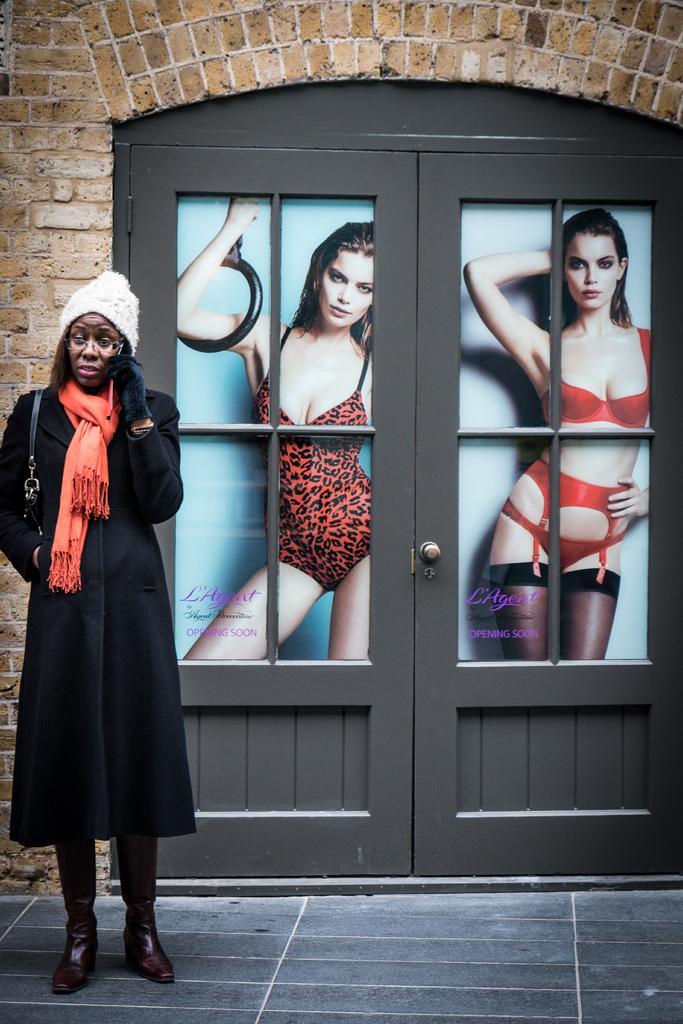Describe this image in one or two sentences. There is a woman standing on the floor and she has spectacles. In the background we can see a wall, door, and posters. 